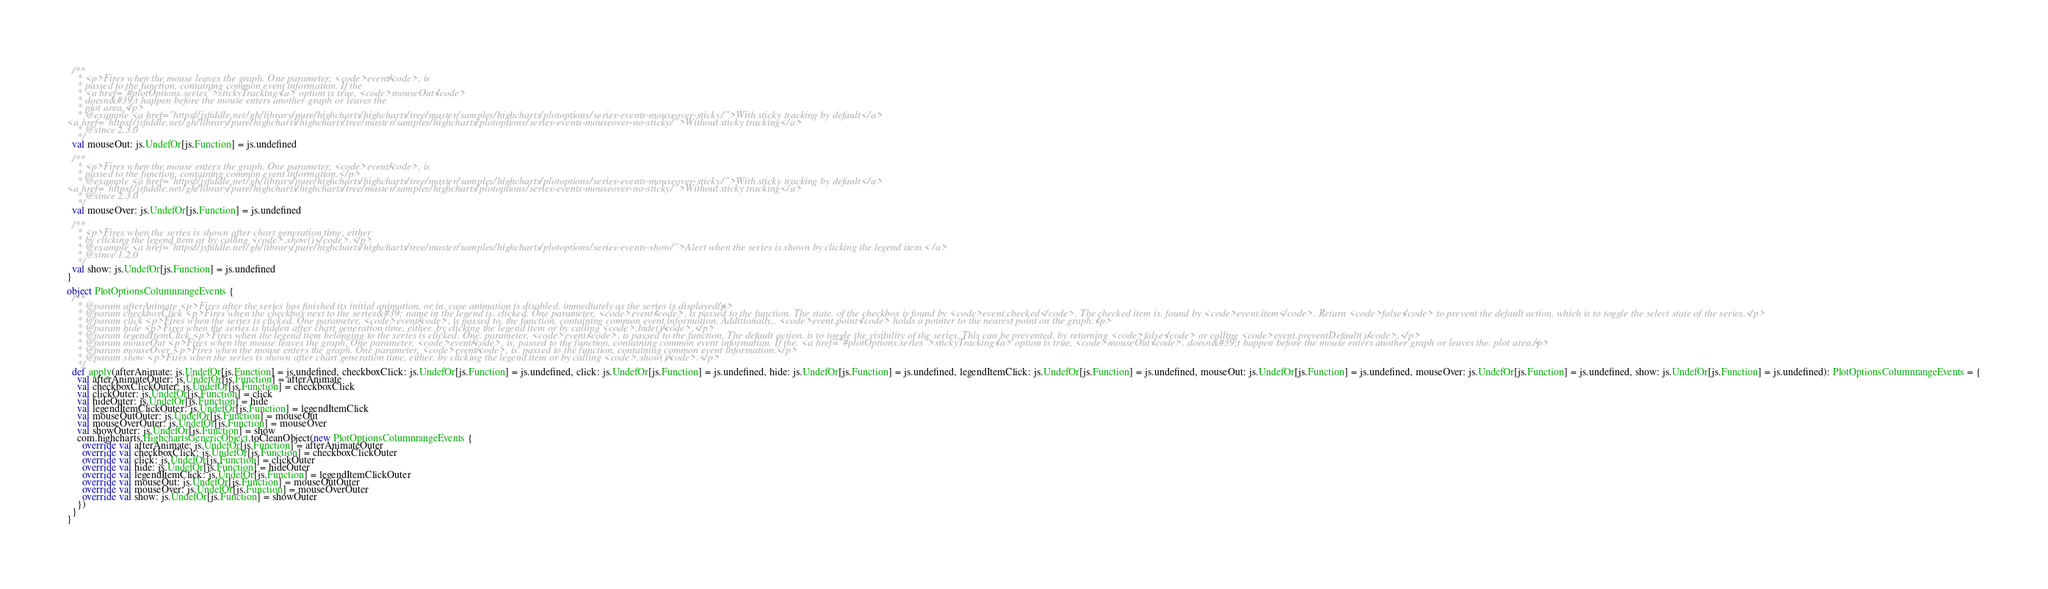<code> <loc_0><loc_0><loc_500><loc_500><_Scala_>
  /**
    * <p>Fires when the mouse leaves the graph. One parameter, <code>event</code>, is
    * passed to the function, containing common event information. If the
    * <a href="#plotOptions.series">stickyTracking</a> option is true, <code>mouseOut</code>
    * doesn&#39;t happen before the mouse enters another graph or leaves the
    * plot area.</p>
    * @example <a href="https://jsfiddle.net/gh/library/pure/highcharts/highcharts/tree/master/samples/highcharts/plotoptions/series-events-mouseover-sticky/">With sticky tracking by default</a>
<a href="https://jsfiddle.net/gh/library/pure/highcharts/highcharts/tree/master/samples/highcharts/plotoptions/series-events-mouseover-no-sticky/">Without sticky tracking</a>
    * @since 2.3.0
    */
  val mouseOut: js.UndefOr[js.Function] = js.undefined

  /**
    * <p>Fires when the mouse enters the graph. One parameter, <code>event</code>, is
    * passed to the function, containing common event information.</p>
    * @example <a href="https://jsfiddle.net/gh/library/pure/highcharts/highcharts/tree/master/samples/highcharts/plotoptions/series-events-mouseover-sticky/">With sticky tracking by default</a>
<a href="https://jsfiddle.net/gh/library/pure/highcharts/highcharts/tree/master/samples/highcharts/plotoptions/series-events-mouseover-no-sticky/">Without sticky tracking</a>
    * @since 2.3.0
    */
  val mouseOver: js.UndefOr[js.Function] = js.undefined

  /**
    * <p>Fires when the series is shown after chart generation time, either
    * by clicking the legend item or by calling <code>.show()</code>.</p>
    * @example <a href="https://jsfiddle.net/gh/library/pure/highcharts/highcharts/tree/master/samples/highcharts/plotoptions/series-events-show/">Alert when the series is shown by clicking the legend item.</a>
    * @since 1.2.0
    */
  val show: js.UndefOr[js.Function] = js.undefined
}

object PlotOptionsColumnrangeEvents {
  /**
    * @param afterAnimate <p>Fires after the series has finished its initial animation, or in. case animation is disabled, immediately as the series is displayed.</p>
    * @param checkboxClick <p>Fires when the checkbox next to the series&#39; name in the legend is. clicked. One parameter, <code>event</code>, is passed to the function. The state. of the checkbox is found by <code>event.checked</code>. The checked item is. found by <code>event.item</code>. Return <code>false</code> to prevent the default action. which is to toggle the select state of the series.</p>
    * @param click <p>Fires when the series is clicked. One parameter, <code>event</code>, is passed to. the function, containing common event information. Additionally,. <code>event.point</code> holds a pointer to the nearest point on the graph.</p>
    * @param hide <p>Fires when the series is hidden after chart generation time, either. by clicking the legend item or by calling <code>.hide()</code>.</p>
    * @param legendItemClick <p>Fires when the legend item belonging to the series is clicked. One. parameter, <code>event</code>, is passed to the function. The default action. is to toggle the visibility of the series. This can be prevented. by returning <code>false</code> or calling <code>event.preventDefault()</code>.</p>
    * @param mouseOut <p>Fires when the mouse leaves the graph. One parameter, <code>event</code>, is. passed to the function, containing common event information. If the. <a href="#plotOptions.series">stickyTracking</a> option is true, <code>mouseOut</code>. doesn&#39;t happen before the mouse enters another graph or leaves the. plot area.</p>
    * @param mouseOver <p>Fires when the mouse enters the graph. One parameter, <code>event</code>, is. passed to the function, containing common event information.</p>
    * @param show <p>Fires when the series is shown after chart generation time, either. by clicking the legend item or by calling <code>.show()</code>.</p>
    */
  def apply(afterAnimate: js.UndefOr[js.Function] = js.undefined, checkboxClick: js.UndefOr[js.Function] = js.undefined, click: js.UndefOr[js.Function] = js.undefined, hide: js.UndefOr[js.Function] = js.undefined, legendItemClick: js.UndefOr[js.Function] = js.undefined, mouseOut: js.UndefOr[js.Function] = js.undefined, mouseOver: js.UndefOr[js.Function] = js.undefined, show: js.UndefOr[js.Function] = js.undefined): PlotOptionsColumnrangeEvents = {
    val afterAnimateOuter: js.UndefOr[js.Function] = afterAnimate
    val checkboxClickOuter: js.UndefOr[js.Function] = checkboxClick
    val clickOuter: js.UndefOr[js.Function] = click
    val hideOuter: js.UndefOr[js.Function] = hide
    val legendItemClickOuter: js.UndefOr[js.Function] = legendItemClick
    val mouseOutOuter: js.UndefOr[js.Function] = mouseOut
    val mouseOverOuter: js.UndefOr[js.Function] = mouseOver
    val showOuter: js.UndefOr[js.Function] = show
    com.highcharts.HighchartsGenericObject.toCleanObject(new PlotOptionsColumnrangeEvents {
      override val afterAnimate: js.UndefOr[js.Function] = afterAnimateOuter
      override val checkboxClick: js.UndefOr[js.Function] = checkboxClickOuter
      override val click: js.UndefOr[js.Function] = clickOuter
      override val hide: js.UndefOr[js.Function] = hideOuter
      override val legendItemClick: js.UndefOr[js.Function] = legendItemClickOuter
      override val mouseOut: js.UndefOr[js.Function] = mouseOutOuter
      override val mouseOver: js.UndefOr[js.Function] = mouseOverOuter
      override val show: js.UndefOr[js.Function] = showOuter
    })
  }
}
</code> 